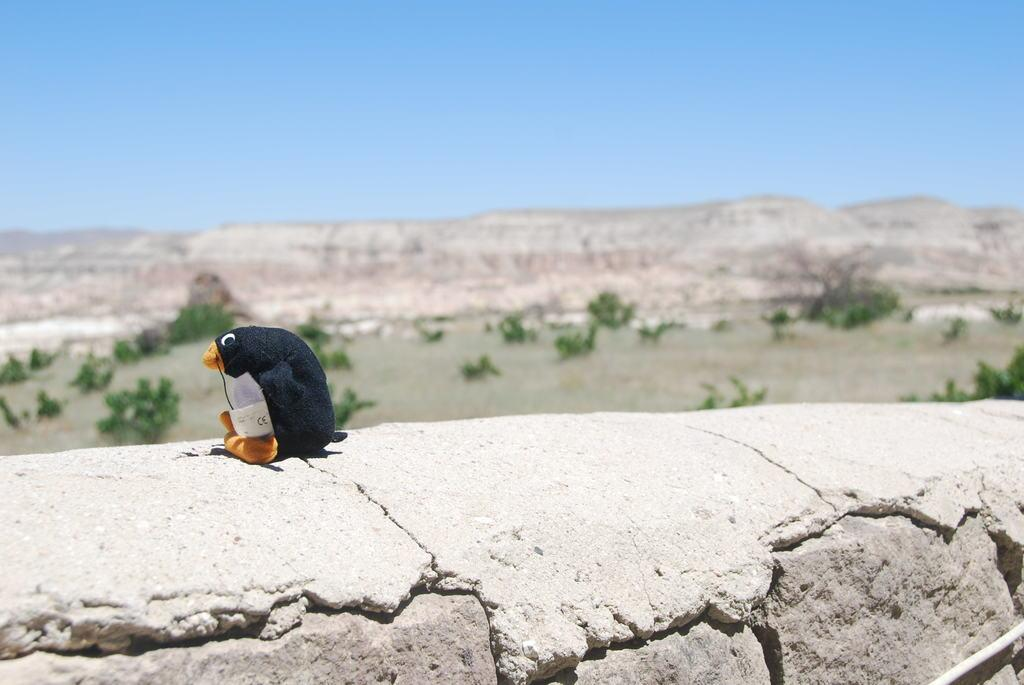What is hanging on the wall in the image? There is a toy on the wall in the image. What can be seen at the top of the image? The sky is visible at the top of the image. What type of landscape feature is visible in the image? There is a hill visible in the image. What celestial bodies are present in the image? Planets are visible in the middle of the image. What type of mine is visible in the image? There is no mine present in the image. What holiday is being celebrated in the image? There is no indication of a holiday being celebrated in the image. 